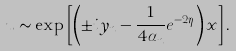Convert formula to latex. <formula><loc_0><loc_0><loc_500><loc_500>u \sim \exp \left [ \left ( \pm i y _ { n } - \frac { 1 } { 4 \alpha _ { n } } e ^ { - 2 \eta } \right ) x \right ] .</formula> 